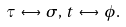<formula> <loc_0><loc_0><loc_500><loc_500>\tau \, \leftrightarrow \, \sigma , \, t \, \leftrightarrow \, \phi .</formula> 